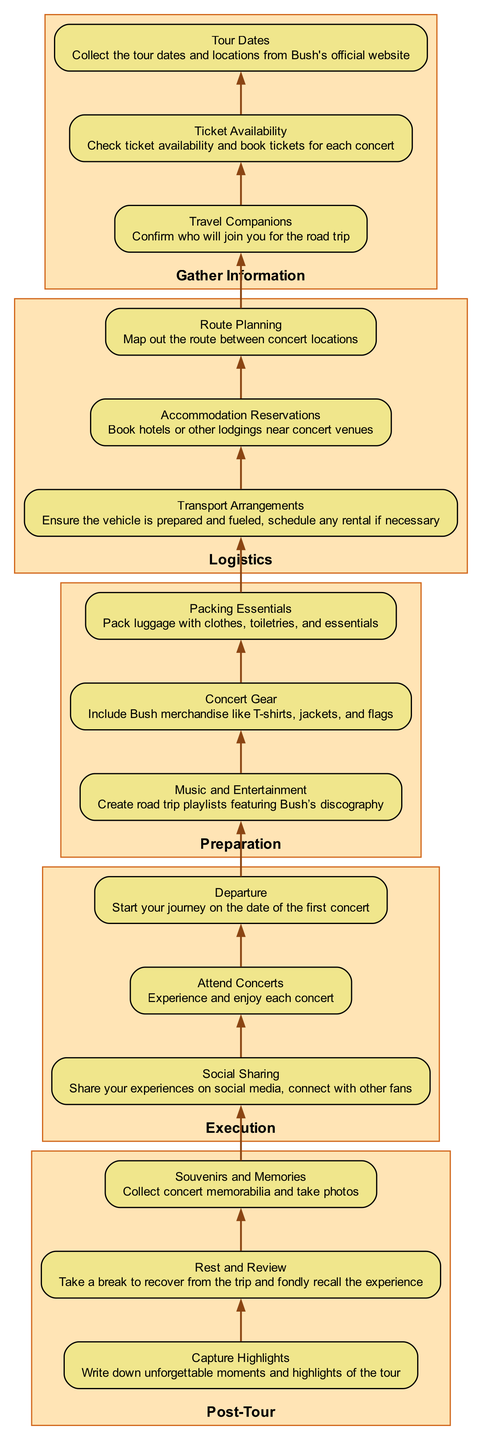What is the first step in planning the road trip? The first step listed is "Gather Information," which contains subcategories for collecting tour dates, ticket availability, and confirming travel companions. Since this is the first main category, it represents the initial action needed for the planning process.
Answer: Gather Information How many main categories are in the diagram? The diagram comprises five main categories: Gather Information, Logistics, Preparation, Execution, and Post-Tour. Counting these categories gives you the total number.
Answer: Five What is included under "Preparation"? Under "Preparation," the items listed are "Packing Essentials," "Concert Gear," and "Music and Entertainment." Those are the specific tasks laid out for this stage of planning.
Answer: Packing Essentials, Concert Gear, Music and Entertainment What must you do before "Departure"? Before "Departure," you need to complete the tasks listed under "Execution," which includes attending concerts, sharing on social media, and taking note of your experiences. These tasks are interconnected as they lead up to the successful completion of the trip.
Answer: Attend Concerts Which category comes after "Logistics"? The category that comes after "Logistics" is "Preparation." This flow shows that after planning logistical aspects like routes and accommodations, the next logical step involves preparing the necessary items for the trip.
Answer: Preparation What do you need to create in the "Preparation" stage? In the "Preparation" stage, it is essential to create a playlist featuring Bush’s discography. This is a way to ensure entertainment during the road trip, linking the music directly to Bush.
Answer: Create road trip playlists featuring Bush’s discography How many steps are there in the "Post-Tour" category? The "Post-Tour" category includes three steps: collecting souvenirs and memories, taking a rest and review, and capturing highlights. To find this, simply count each of the listed items in this category.
Answer: Three What action is taken last in this planning process? The last action noted in the process is to "Capture Highlights," which involves writing down unforgettable moments and highlights of the tour, representing the completion of the overall experience and summary actions following the concerts.
Answer: Capture Highlights What should you confirm in the "Gather Information" step? In the "Gather Information" step, you need to confirm who will join you for the road trip. This step is crucial as it affects all other logistical and planning decisions to follow.
Answer: Confirm who will join you for the road trip 